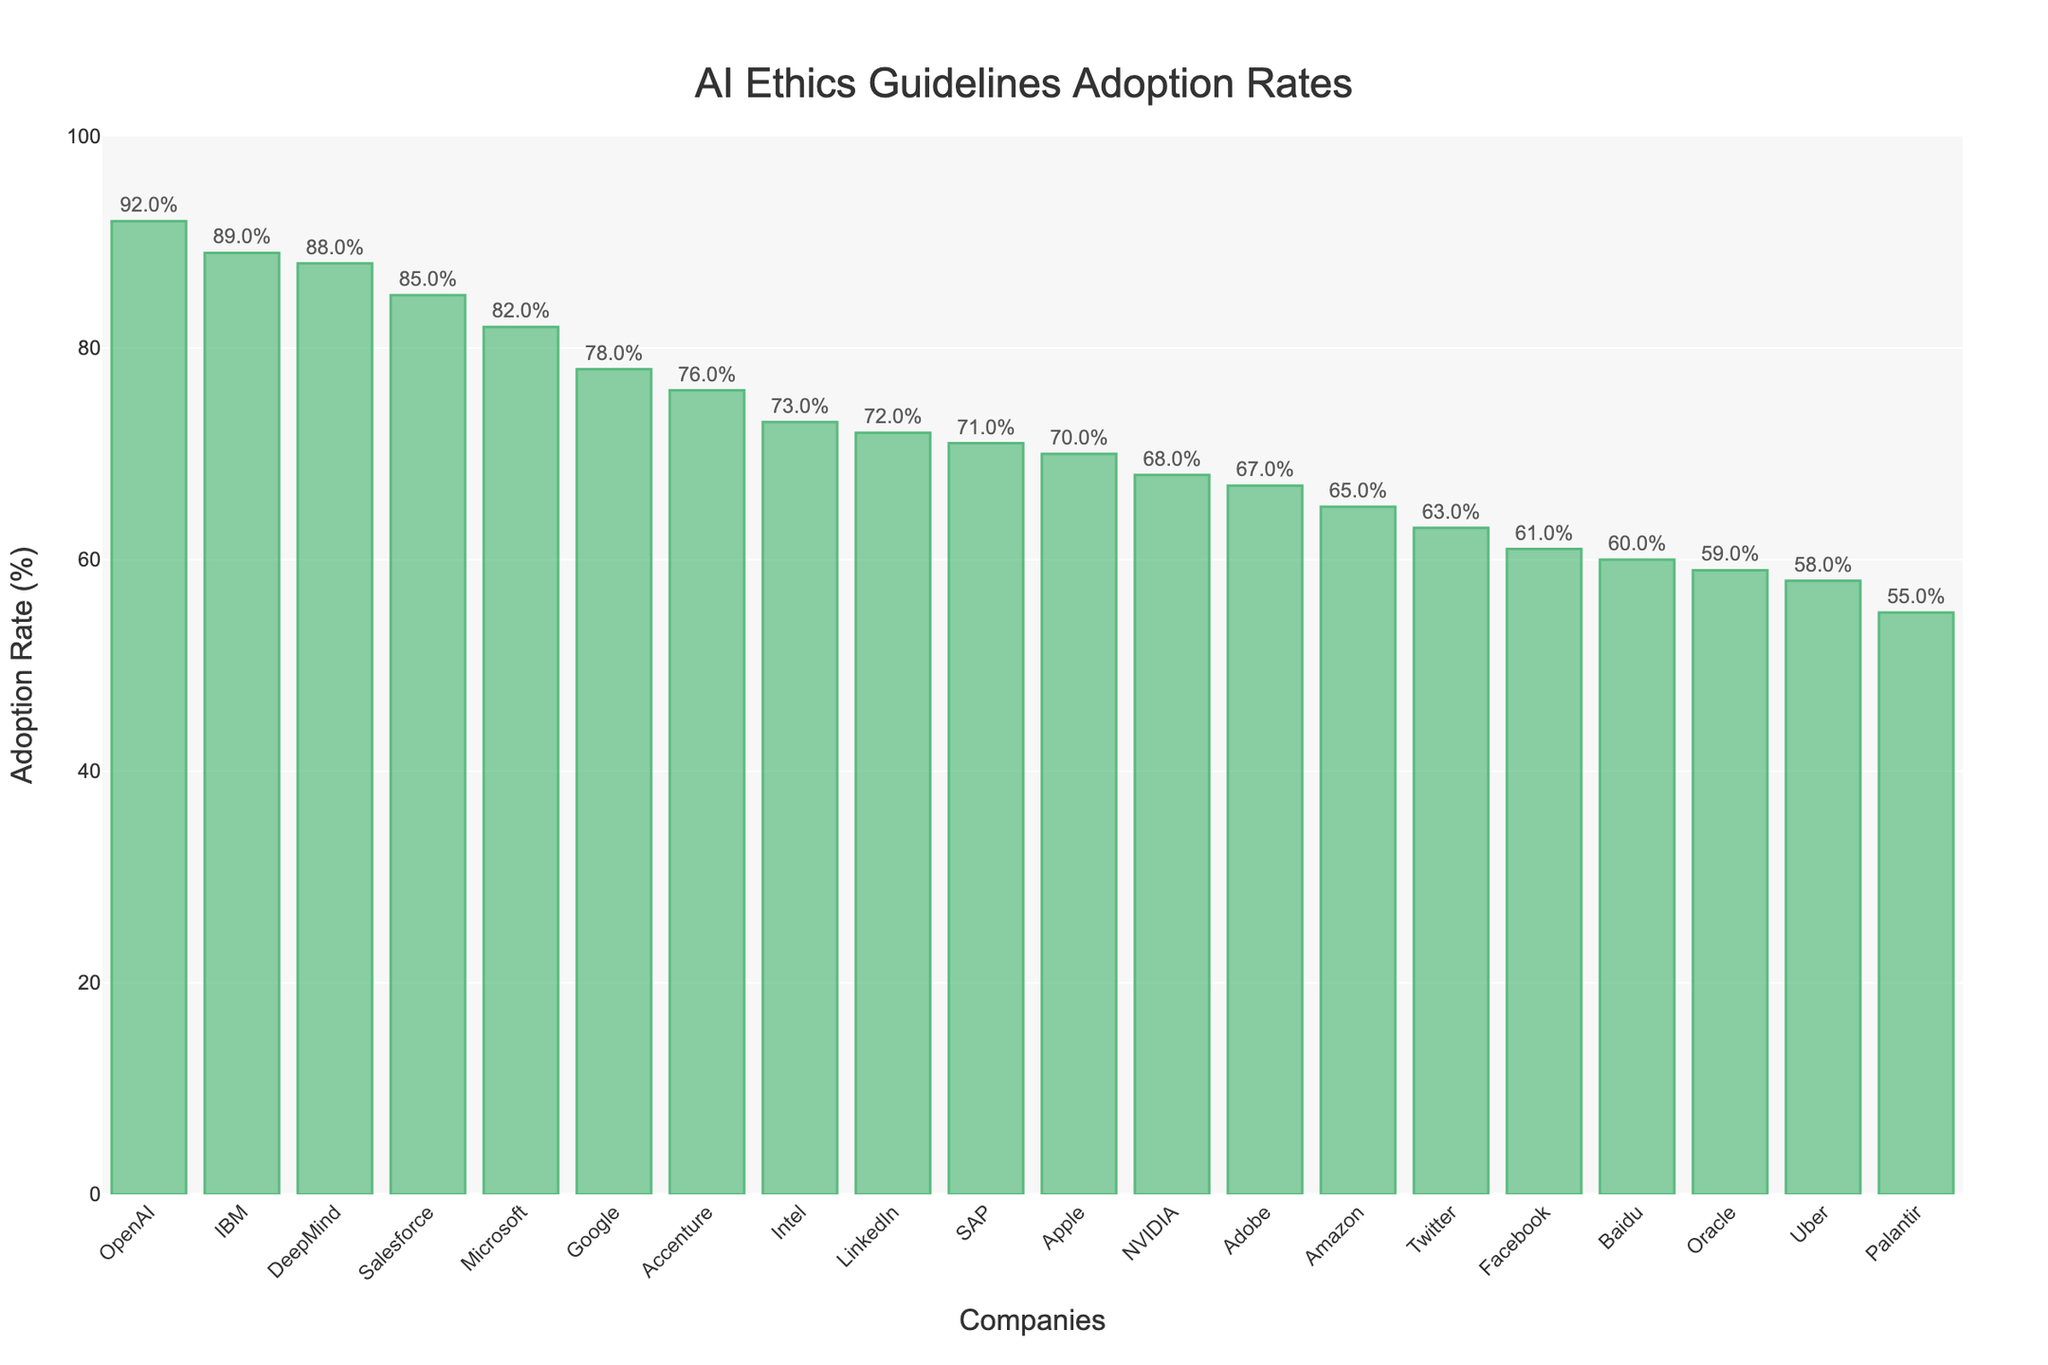Which company has the highest adoption rate of AI ethics guidelines? By visually inspecting the heights of the bars, the bar representing "OpenAI" is the tallest. This indicates that OpenAI has the highest adoption rate.
Answer: OpenAI What is the difference in adoption rates between the company with the highest and the company with the lowest adoption rate? Identify the tallest bar (OpenAI at 92%) and the shortest bar (Palantir at 55%). Subtract the smallest adoption rate from the largest: 92% - 55%.
Answer: 37% Which companies have adoption rates above 80%? Look for bars that reach above the 80% mark. These companies are Microsoft (82%), IBM (89%), Salesforce (85%), OpenAI (92%), and DeepMind (88%).
Answer: Microsoft, IBM, Salesforce, OpenAI, DeepMind What is the average adoption rate of AI ethics guidelines for Google, Amazon, and Facebook? Identify the adoption rates: Google (78%), Amazon (65%), Facebook (61%). Sum these values and divide by 3: (78% + 65% + 61%) / 3.
Answer: 68% How many companies have adoption rates below 60%? Identify the companies with bars that fall under the 60% mark: Facebook (61%), Oracle (59%), Palantir (55%), Uber (58%), Baidu (60%). Count them and exclude companies above 60%.
Answer: 5 Which company has a slightly lower adoption rate than NVIDIA? Identify NVIDIA's adoption rate (68%) and look for the company with a bar slightly lower than this: Adobe at 67%.
Answer: Adobe What is the median adoption rate for all listed companies? Arrange the adoption rates in ascending order, find the middle value (if the list length is odd) or average the two middle values (if even). Here, the middle adoption rate in a sorted list is the average of the 10th and 11th values since there are 20 companies: (68% + 70%) / 2.
Answer: 69% Is the adoption rate of AI ethics guidelines higher for IBM or Salesforce? Visually compare the heights of the bars for IBM and Salesforce. IBM's bar is slightly shorter than Salesforce's. IBM has an adoption rate of 89%, whereas Salesforce has 85%.
Answer: IBM What is the total sum of adoption rates for the three companies with the highest rates? Identify the companies with the highest rates: OpenAI (92%), IBM (89%), and Salesforce (85%). Sum up these values: 92% + 89% + 85%.
Answer: 266% 